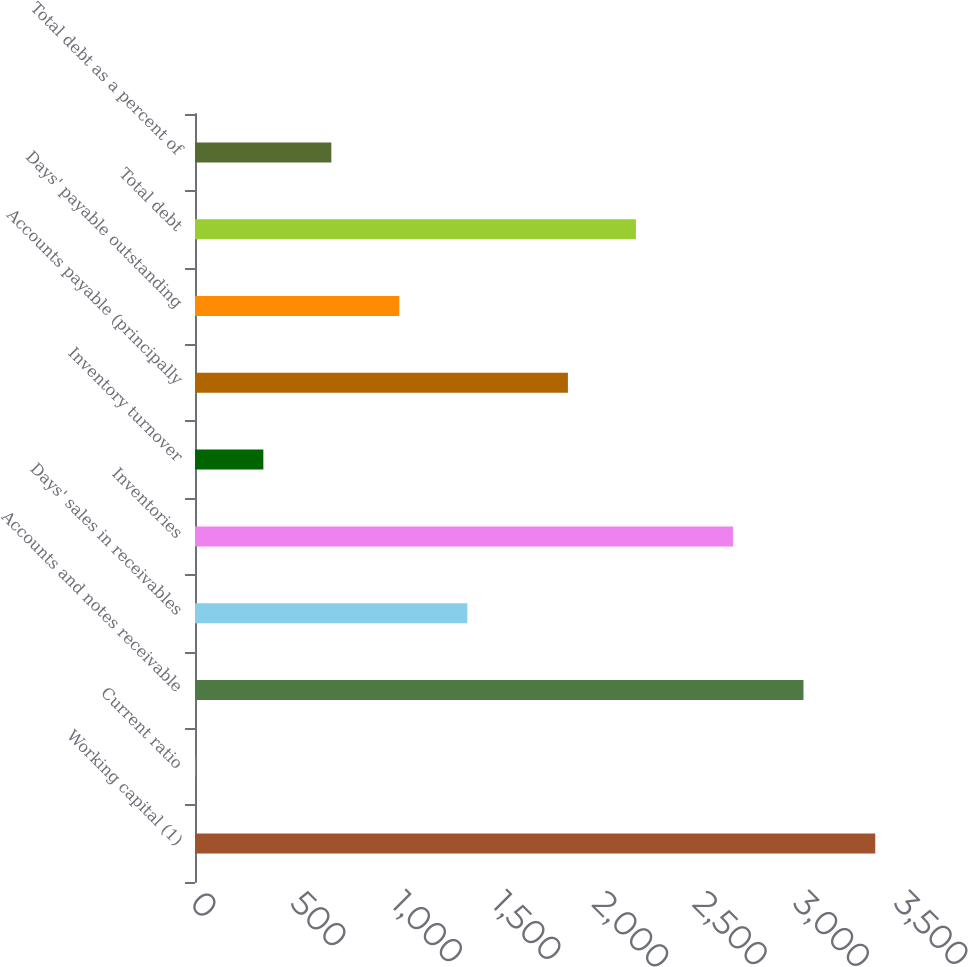Convert chart to OTSL. <chart><loc_0><loc_0><loc_500><loc_500><bar_chart><fcel>Working capital (1)<fcel>Current ratio<fcel>Accounts and notes receivable<fcel>Days' sales in receivables<fcel>Inventories<fcel>Inventory turnover<fcel>Accounts payable (principally<fcel>Days' payable outstanding<fcel>Total debt<fcel>Total debt as a percent of<nl><fcel>3382<fcel>1.78<fcel>3025<fcel>1353.86<fcel>2675<fcel>339.8<fcel>1854<fcel>1015.84<fcel>2192.02<fcel>677.82<nl></chart> 